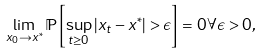<formula> <loc_0><loc_0><loc_500><loc_500>\lim _ { x _ { 0 } \to x ^ { * } } \mathbb { P } \left [ \sup _ { t \geq 0 } | x _ { t } - x ^ { * } | > \epsilon \right ] = 0 \forall \epsilon > 0 ,</formula> 